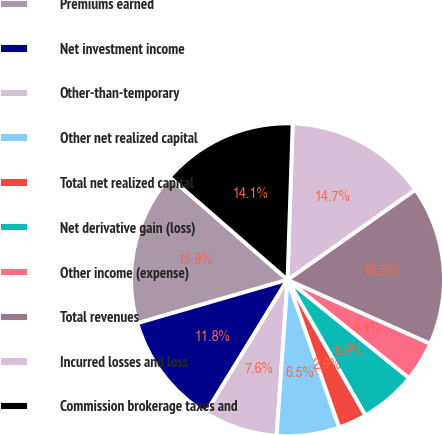Convert chart. <chart><loc_0><loc_0><loc_500><loc_500><pie_chart><fcel>Premiums earned<fcel>Net investment income<fcel>Other-than-temporary<fcel>Other net realized capital<fcel>Total net realized capital<fcel>Net derivative gain (loss)<fcel>Other income (expense)<fcel>Total revenues<fcel>Incurred losses and loss<fcel>Commission brokerage taxes and<nl><fcel>15.88%<fcel>11.76%<fcel>7.65%<fcel>6.47%<fcel>2.94%<fcel>5.88%<fcel>4.12%<fcel>16.47%<fcel>14.71%<fcel>14.12%<nl></chart> 